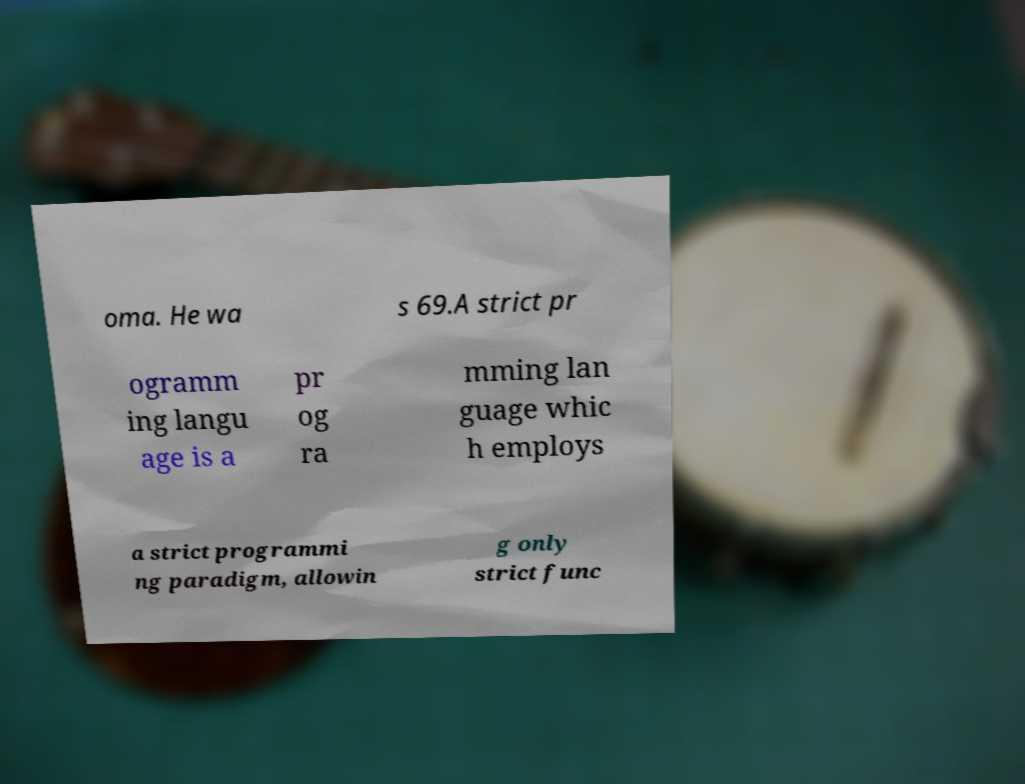What messages or text are displayed in this image? I need them in a readable, typed format. oma. He wa s 69.A strict pr ogramm ing langu age is a pr og ra mming lan guage whic h employs a strict programmi ng paradigm, allowin g only strict func 